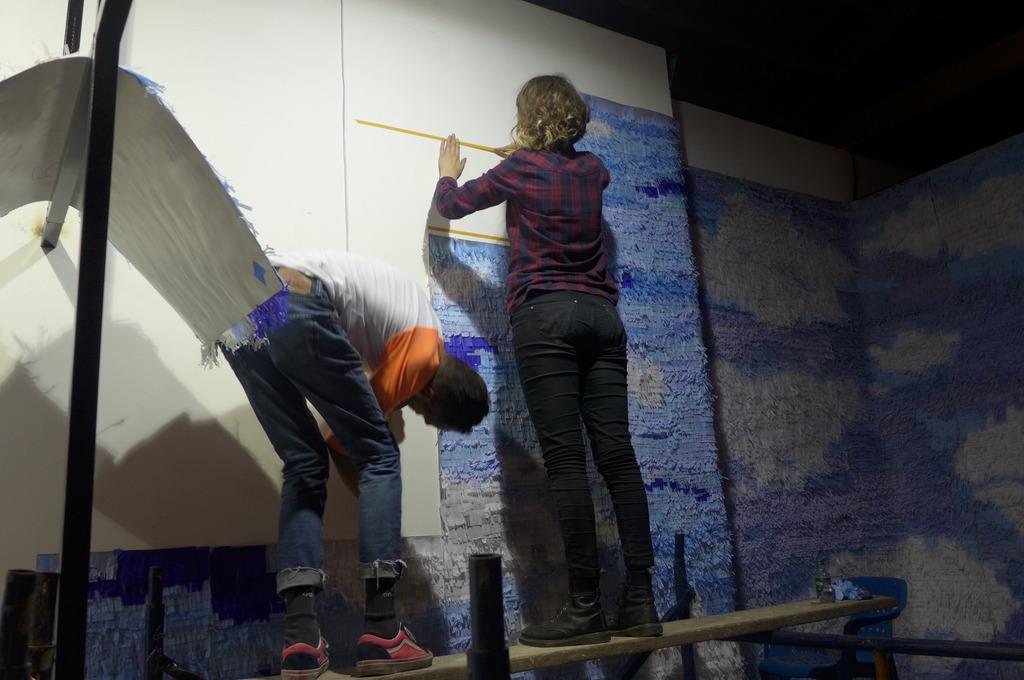Describe this image in one or two sentences. This picture shows a man and a woman standing on the wooden plank and we see woman measuring with the tape and man holding the board. 